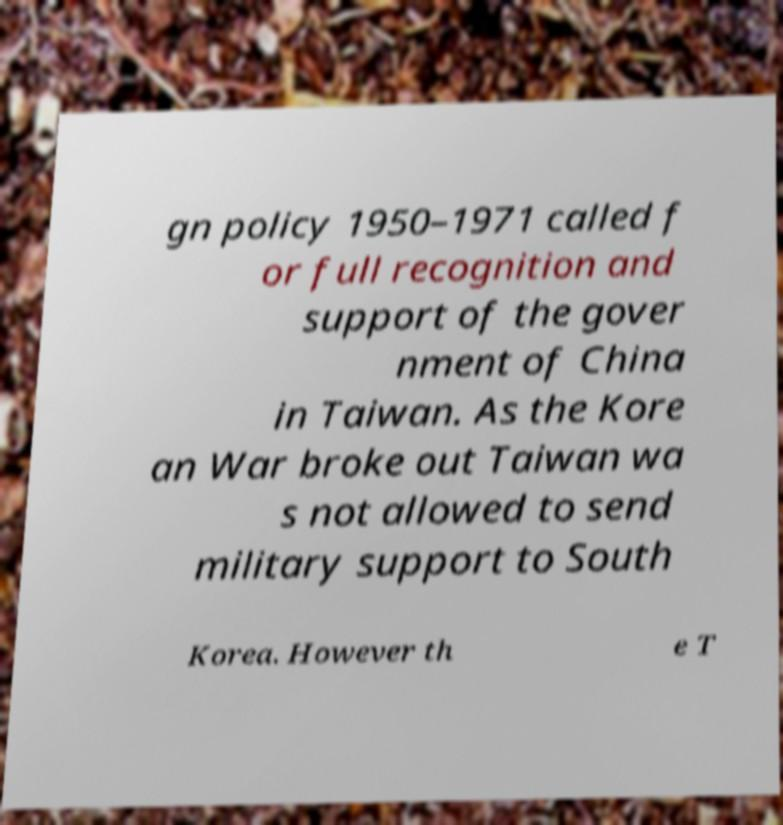Could you assist in decoding the text presented in this image and type it out clearly? gn policy 1950–1971 called f or full recognition and support of the gover nment of China in Taiwan. As the Kore an War broke out Taiwan wa s not allowed to send military support to South Korea. However th e T 